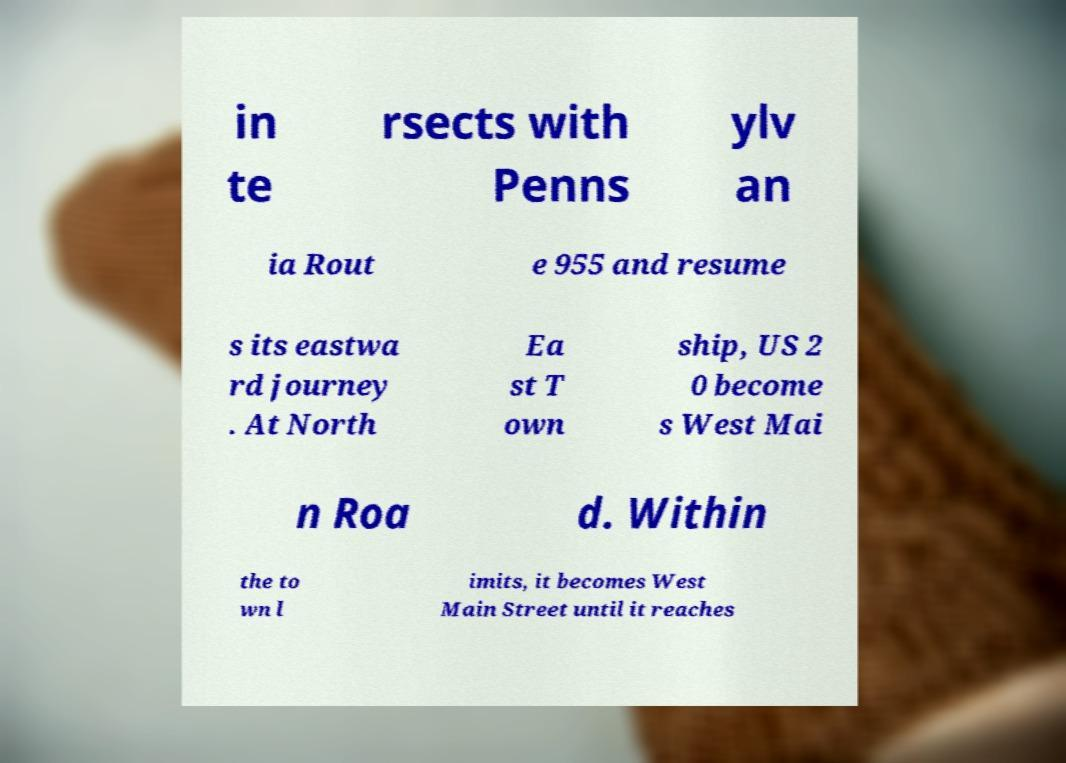I need the written content from this picture converted into text. Can you do that? in te rsects with Penns ylv an ia Rout e 955 and resume s its eastwa rd journey . At North Ea st T own ship, US 2 0 become s West Mai n Roa d. Within the to wn l imits, it becomes West Main Street until it reaches 